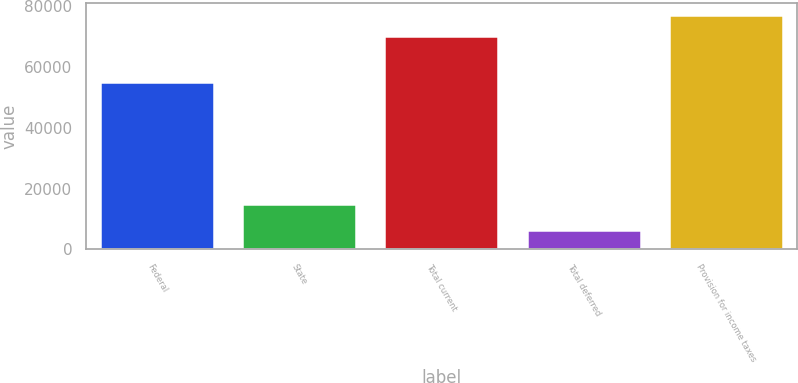<chart> <loc_0><loc_0><loc_500><loc_500><bar_chart><fcel>Federal<fcel>State<fcel>Total current<fcel>Total deferred<fcel>Provision for income taxes<nl><fcel>55104<fcel>14900<fcel>70004<fcel>6328<fcel>77004.4<nl></chart> 